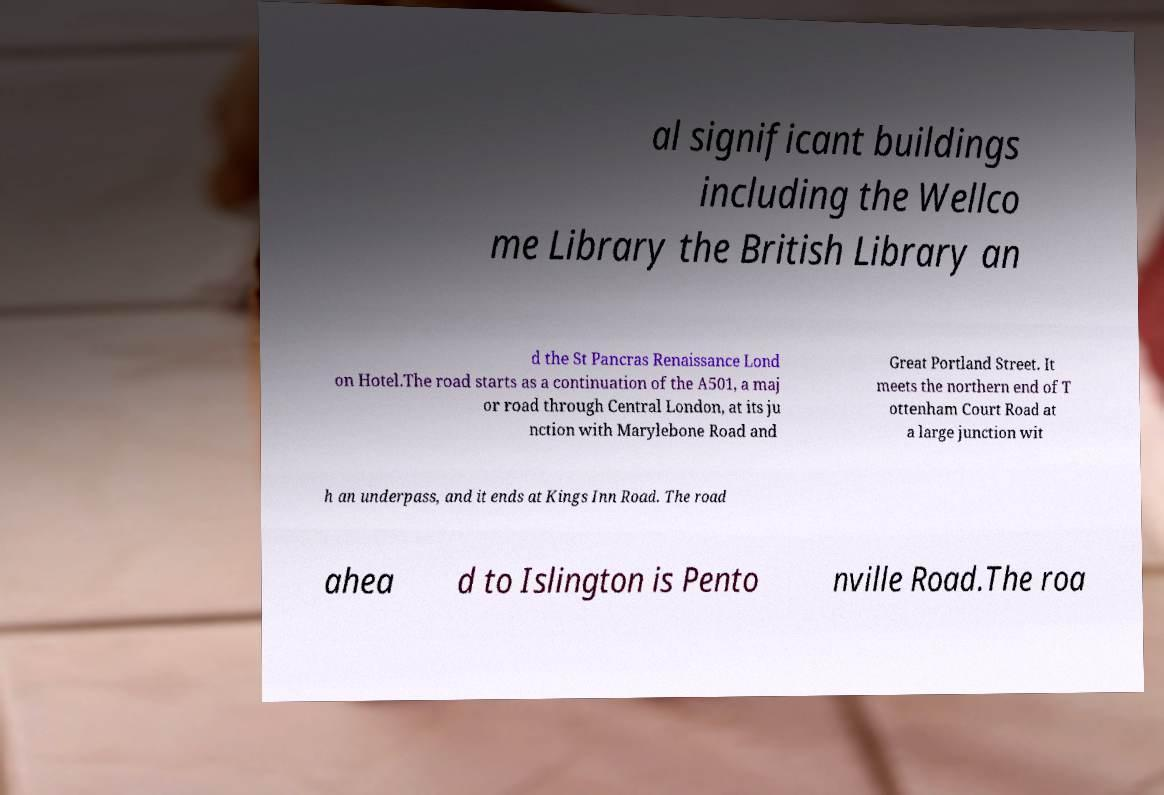There's text embedded in this image that I need extracted. Can you transcribe it verbatim? al significant buildings including the Wellco me Library the British Library an d the St Pancras Renaissance Lond on Hotel.The road starts as a continuation of the A501, a maj or road through Central London, at its ju nction with Marylebone Road and Great Portland Street. It meets the northern end of T ottenham Court Road at a large junction wit h an underpass, and it ends at Kings Inn Road. The road ahea d to Islington is Pento nville Road.The roa 